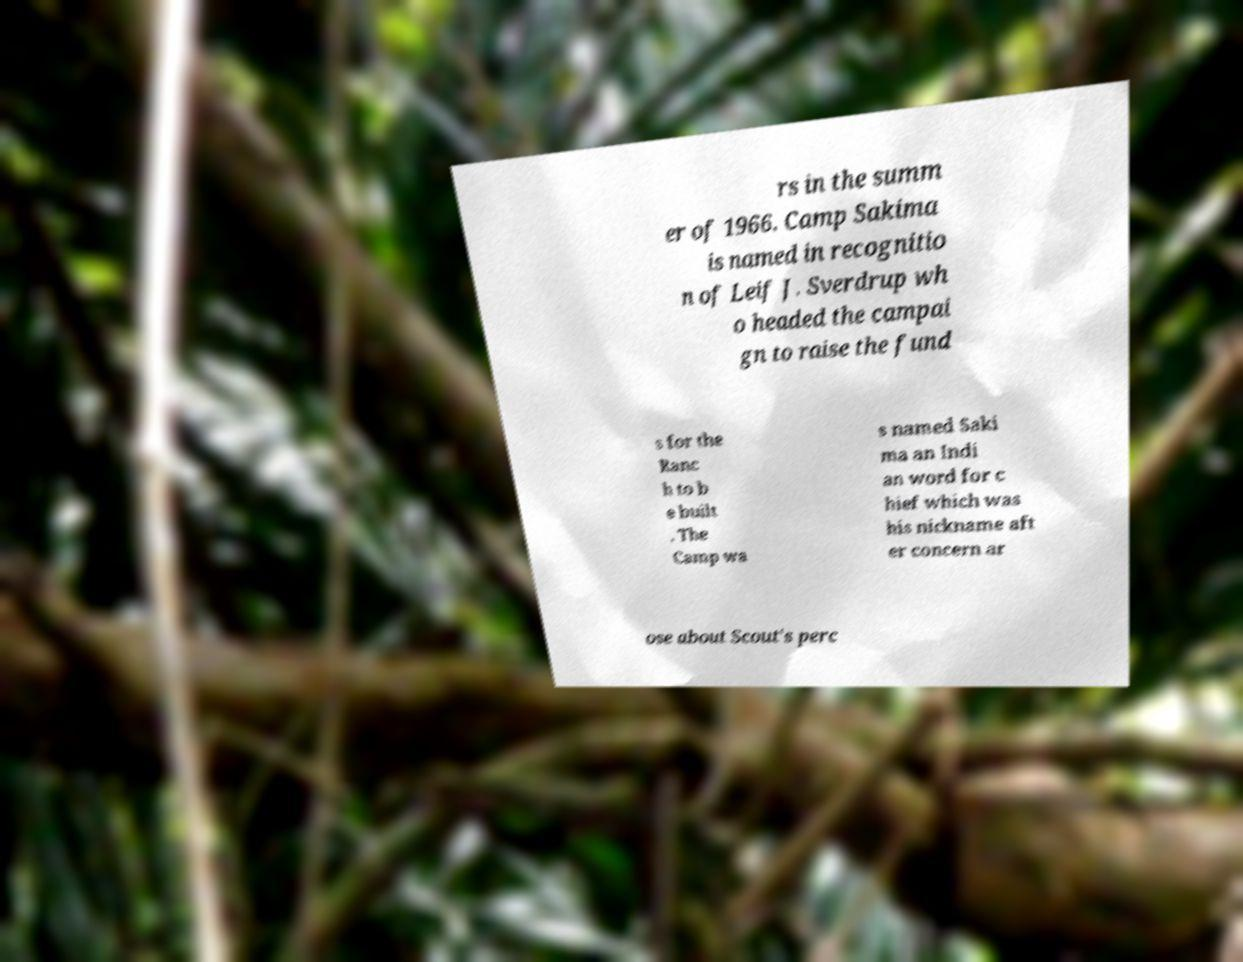What messages or text are displayed in this image? I need them in a readable, typed format. rs in the summ er of 1966. Camp Sakima is named in recognitio n of Leif J. Sverdrup wh o headed the campai gn to raise the fund s for the Ranc h to b e built . The Camp wa s named Saki ma an Indi an word for c hief which was his nickname aft er concern ar ose about Scout's perc 